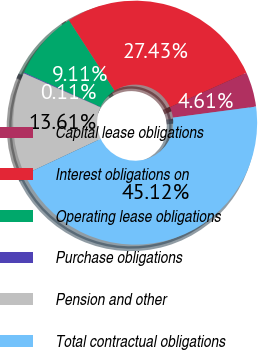Convert chart to OTSL. <chart><loc_0><loc_0><loc_500><loc_500><pie_chart><fcel>Capital lease obligations<fcel>Interest obligations on<fcel>Operating lease obligations<fcel>Purchase obligations<fcel>Pension and other<fcel>Total contractual obligations<nl><fcel>4.61%<fcel>27.43%<fcel>9.11%<fcel>0.11%<fcel>13.61%<fcel>45.12%<nl></chart> 